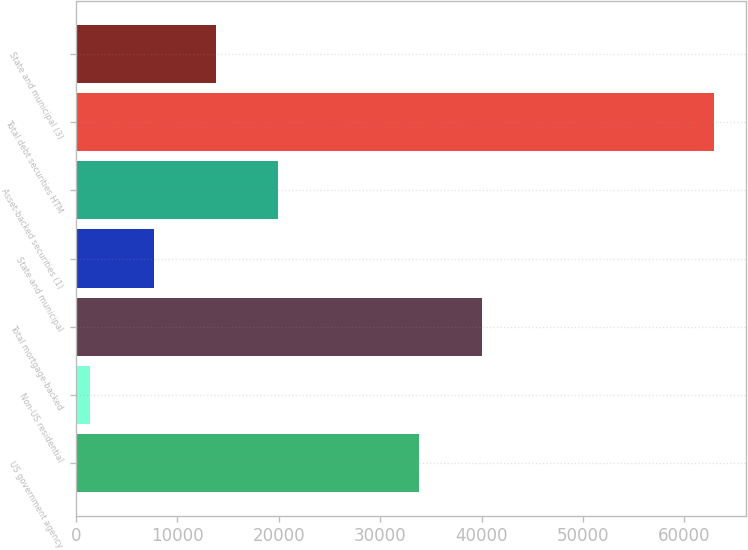<chart> <loc_0><loc_0><loc_500><loc_500><bar_chart><fcel>US government agency<fcel>Non-US residential<fcel>Total mortgage-backed<fcel>State and municipal<fcel>Asset-backed securities (1)<fcel>Total debt securities HTM<fcel>State and municipal (3)<nl><fcel>33860<fcel>1350<fcel>40014<fcel>7657<fcel>19965<fcel>62890<fcel>13811<nl></chart> 